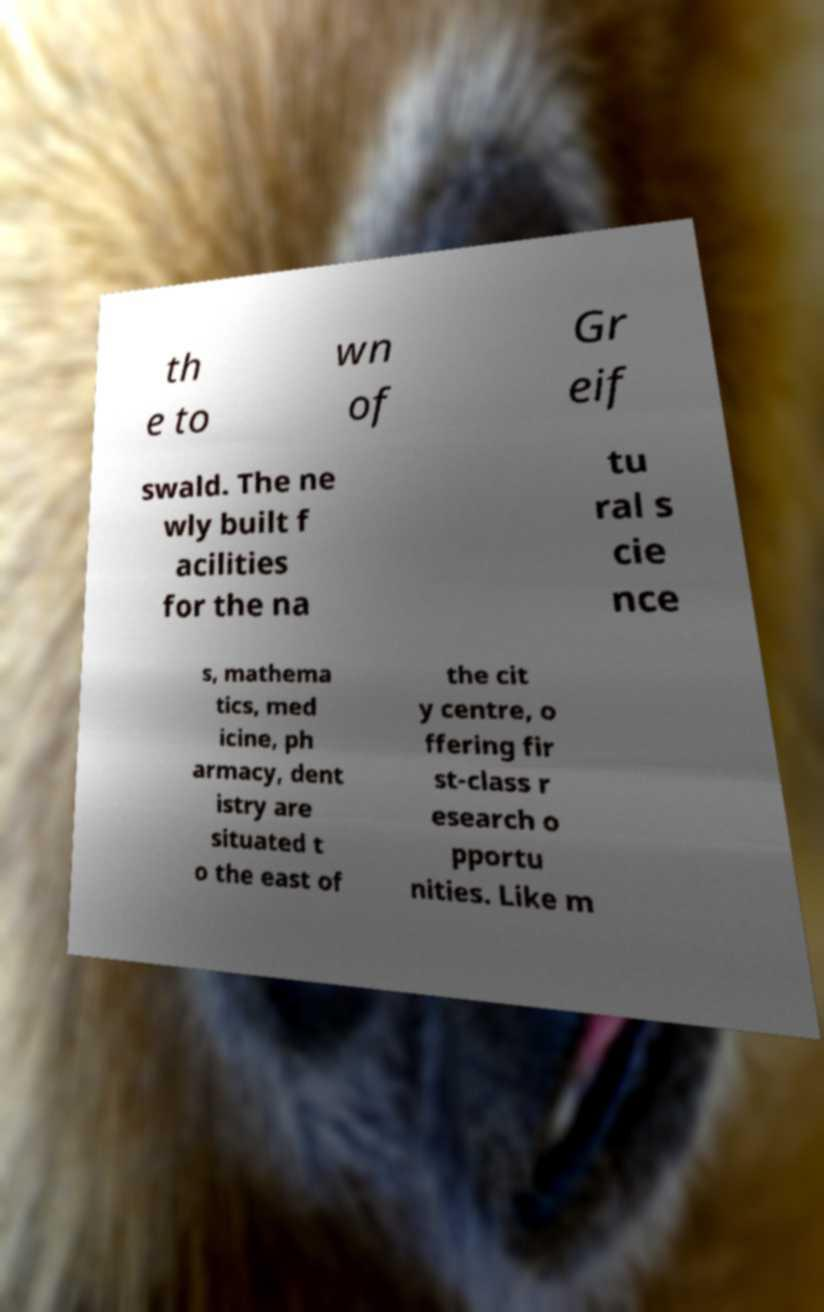I need the written content from this picture converted into text. Can you do that? th e to wn of Gr eif swald. The ne wly built f acilities for the na tu ral s cie nce s, mathema tics, med icine, ph armacy, dent istry are situated t o the east of the cit y centre, o ffering fir st-class r esearch o pportu nities. Like m 